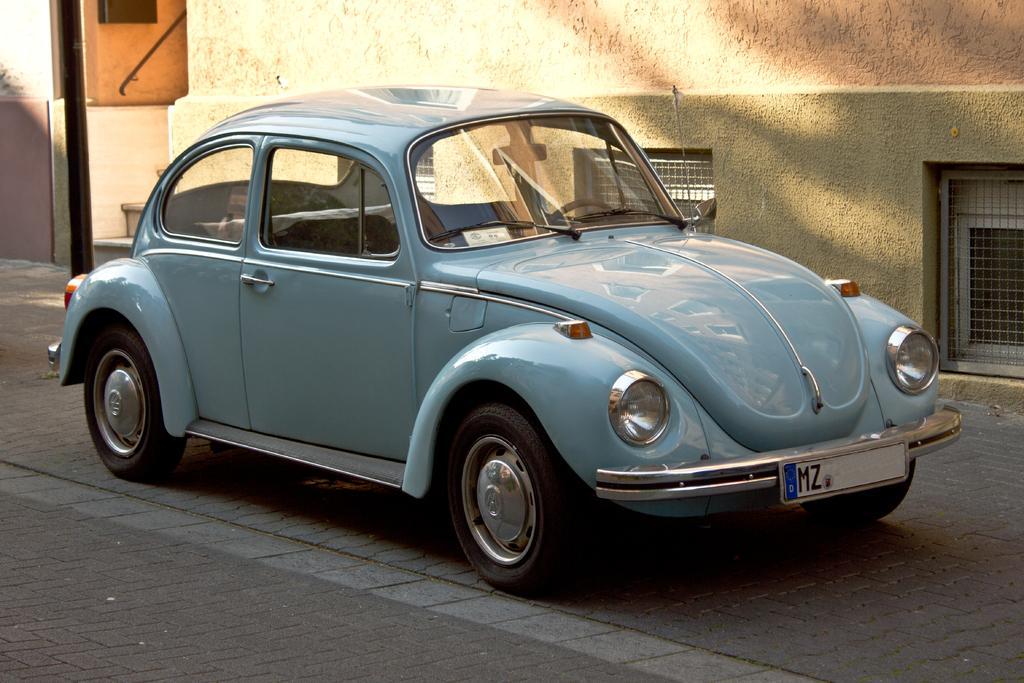Could you give a brief overview of what you see in this image? In the center of the image we can see a car on the road. In the background there is a building. 